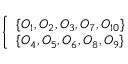Convert formula to latex. <formula><loc_0><loc_0><loc_500><loc_500>\left \{ \begin{array} { l l } { \{ O _ { 1 } , O _ { 2 } , O _ { 3 } , O _ { 7 } , O _ { 1 0 } \} } \\ { \{ O _ { 4 } , O _ { 5 } , O _ { 6 } , O _ { 8 } , O _ { 9 } \} } \end{array}</formula> 